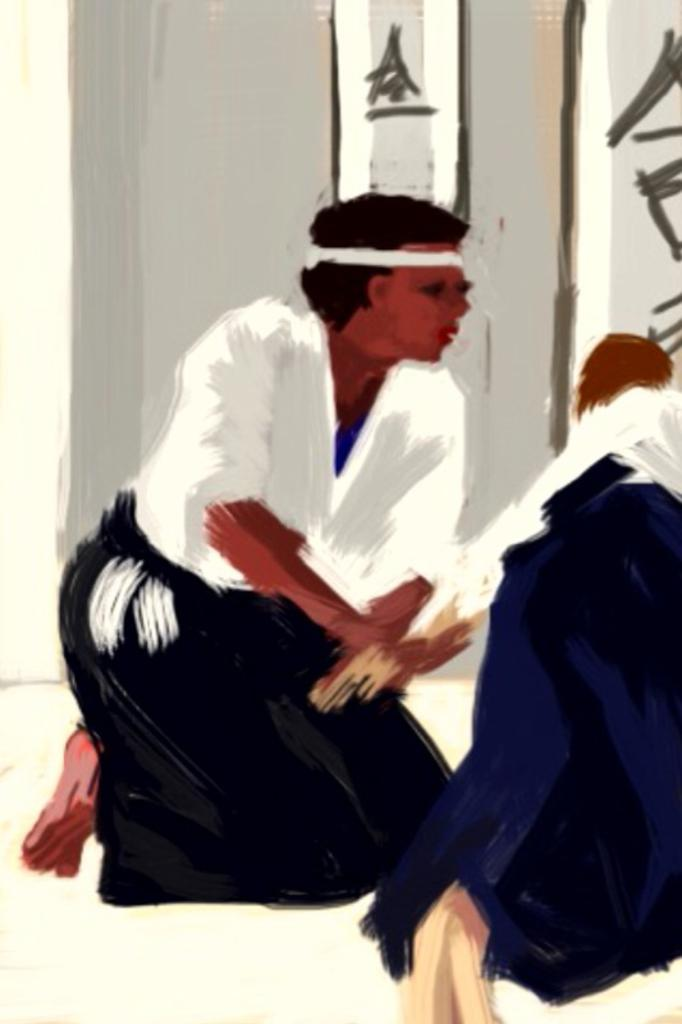What is the main subject of the image? There is a painting in the image. What is depicted in the painting? The painting depicts two people. Is there any text or writing visible in the image? Yes, there is text or writing visible in the image. What type of bird can be seen flying in the painting? There is no bird visible in the painting; it depicts two people. 